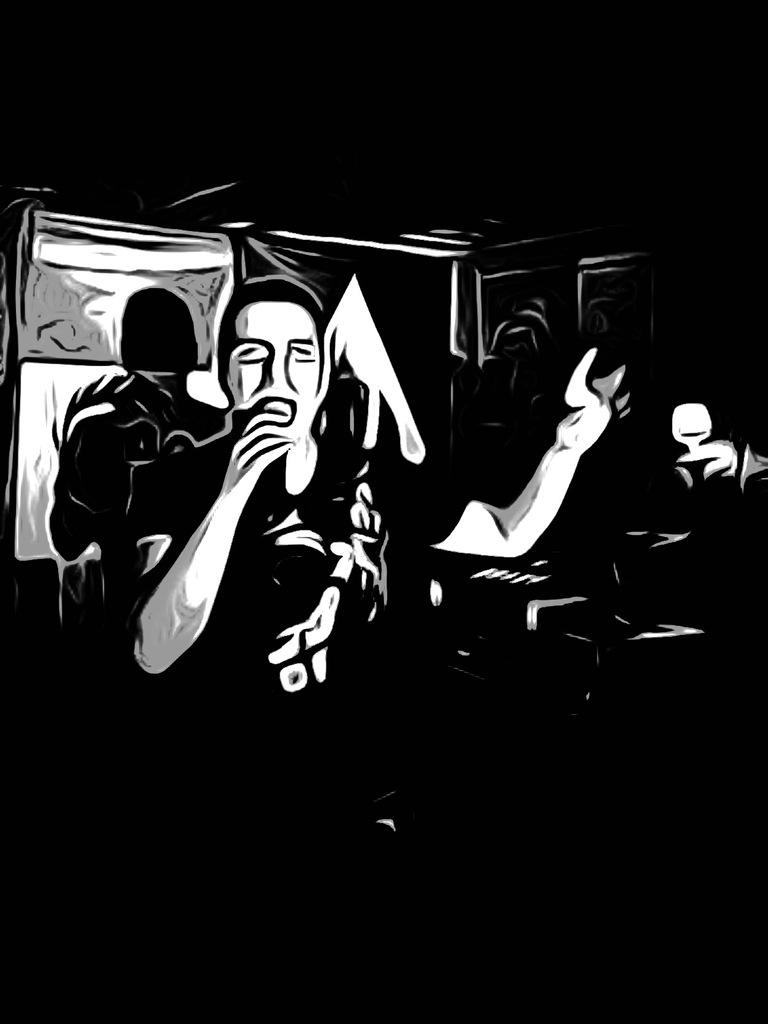What style is the image in? The image is a cartoon. Who or what is shown in the image? There is a person depicted in the image. What color scheme is used in the image? The image is black and white in color. What type of owl can be seen flying in the image? There is no owl present in the image; it is a cartoon depicting a person in black and white. 